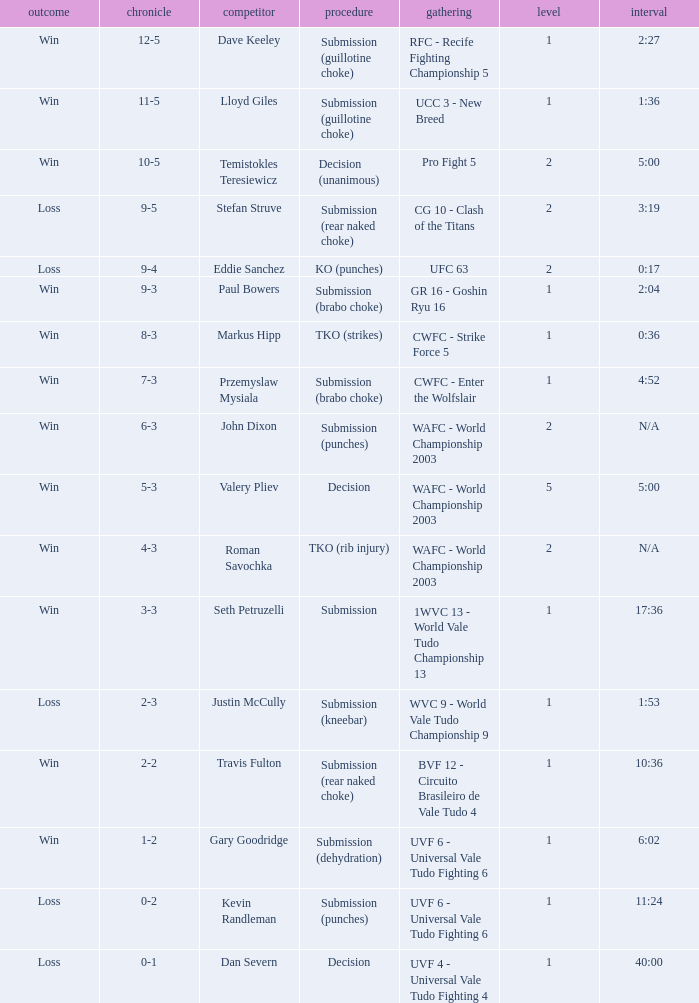What round has the highest Res loss, and a time of 40:00? 1.0. 